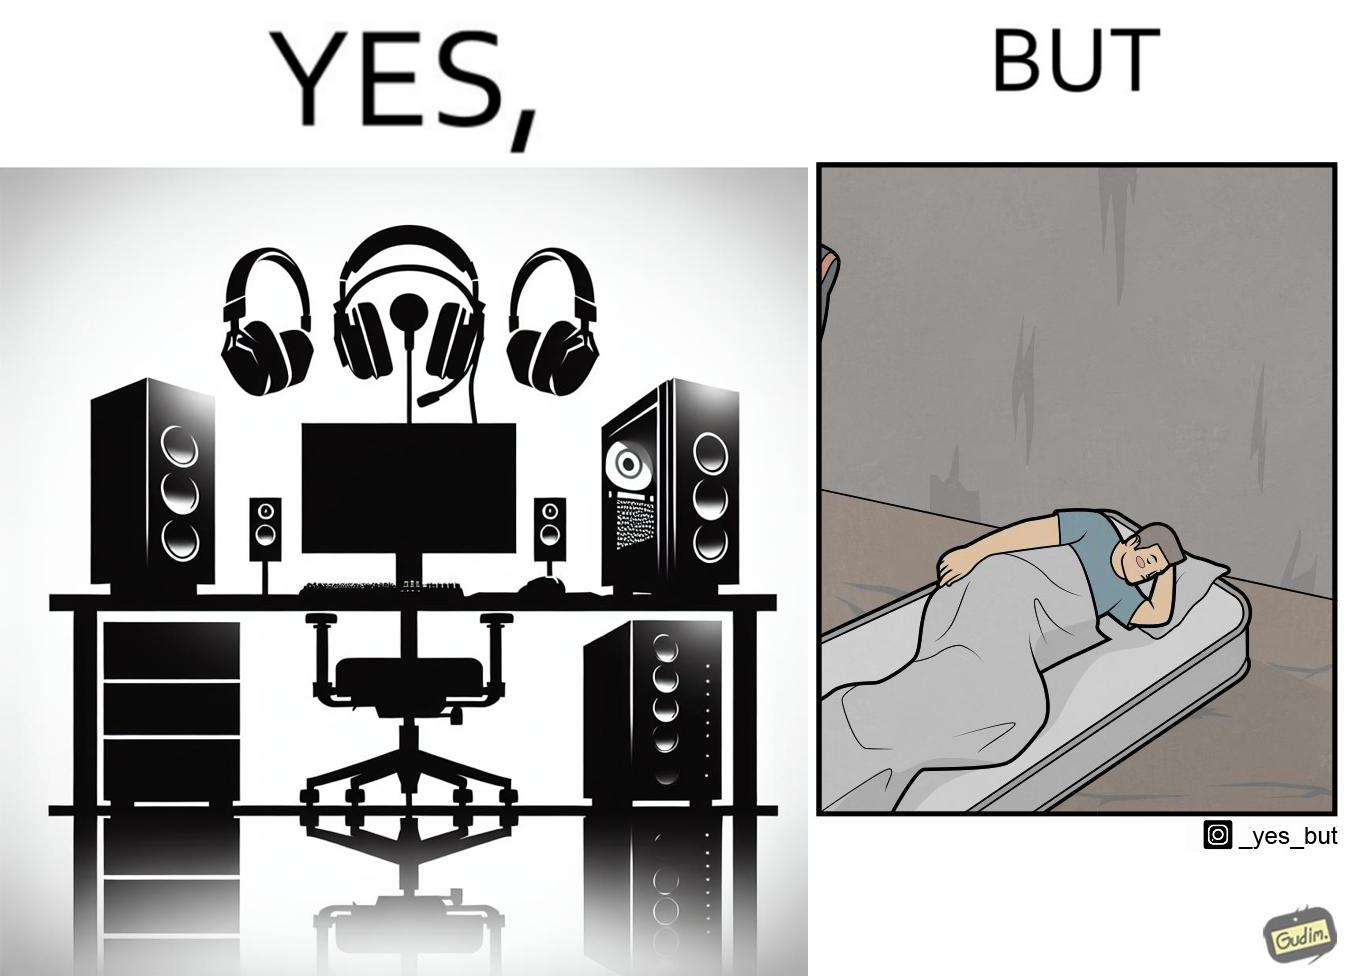What is shown in this image? The image is funny because the person has a lot of furniture for his computer but none for himself. 